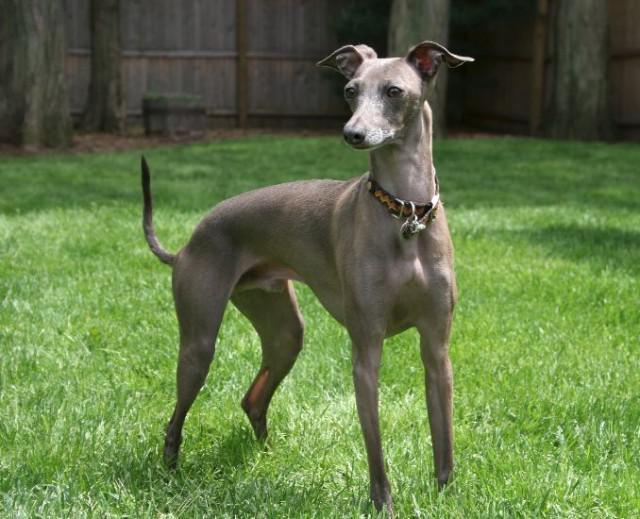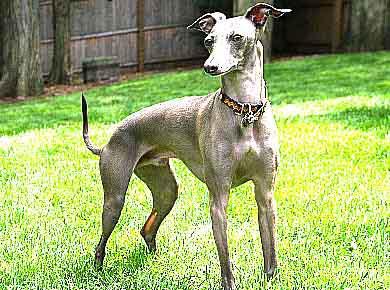The first image is the image on the left, the second image is the image on the right. For the images shown, is this caption "The dog in the right image is standing and facing left" true? Answer yes or no. No. The first image is the image on the left, the second image is the image on the right. Given the left and right images, does the statement "Both of the dogs are wearing collars." hold true? Answer yes or no. Yes. 